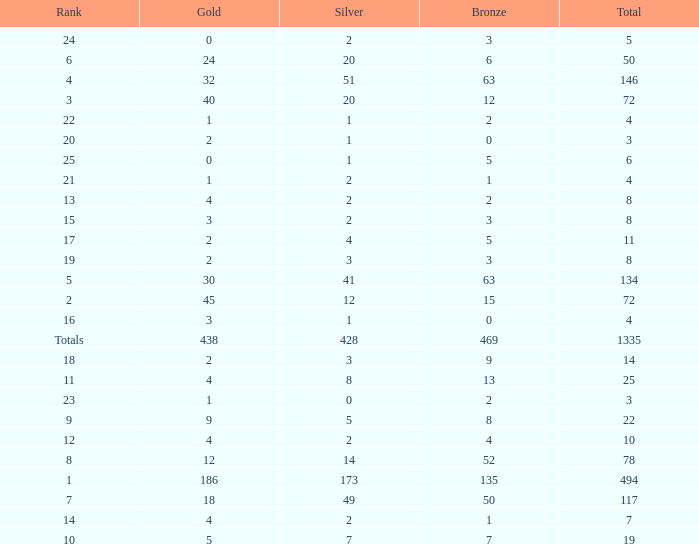What is the number of bronze medals when the total medals were 78 and there were less than 12 golds? None. 